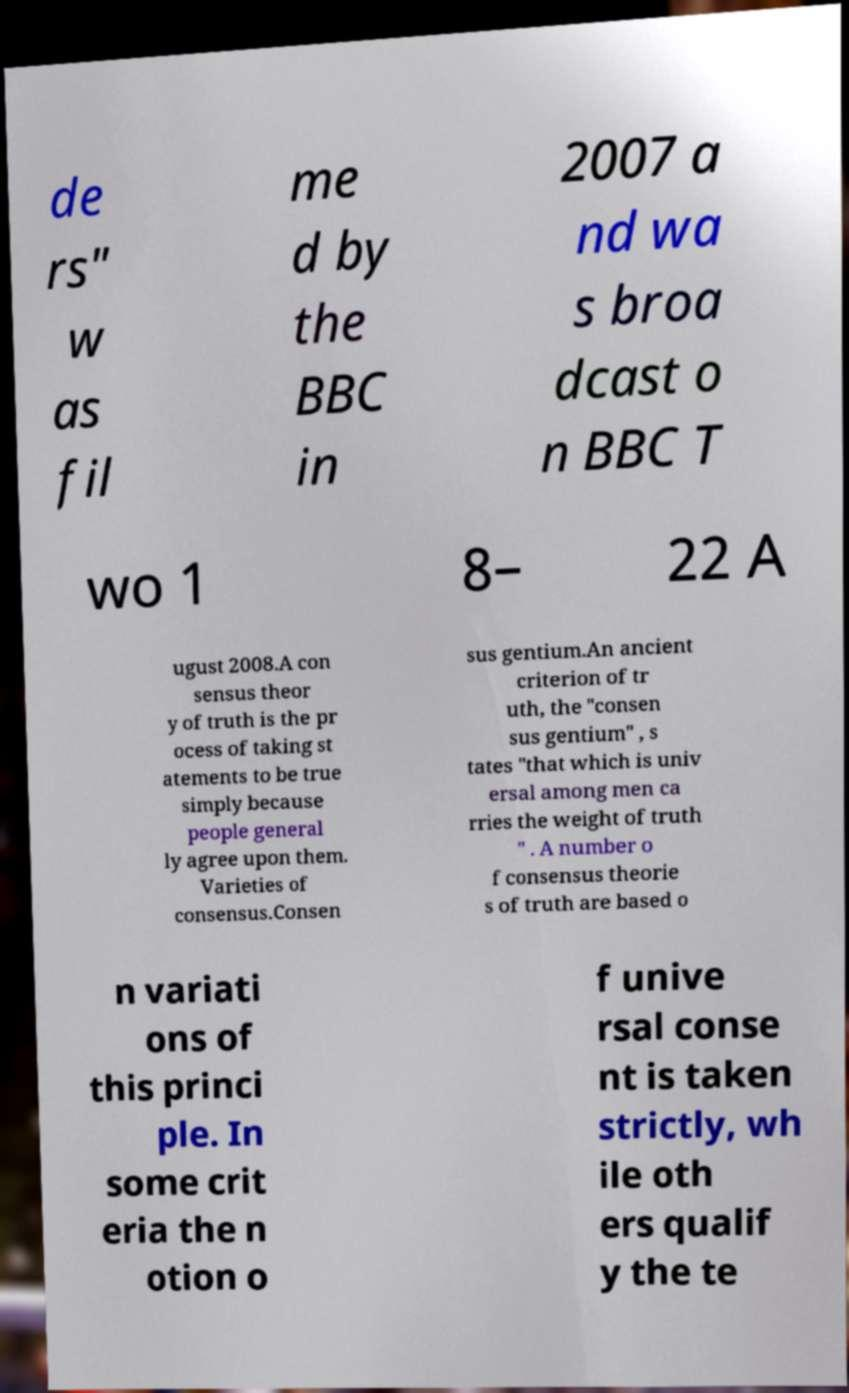Could you extract and type out the text from this image? de rs" w as fil me d by the BBC in 2007 a nd wa s broa dcast o n BBC T wo 1 8– 22 A ugust 2008.A con sensus theor y of truth is the pr ocess of taking st atements to be true simply because people general ly agree upon them. Varieties of consensus.Consen sus gentium.An ancient criterion of tr uth, the "consen sus gentium" , s tates "that which is univ ersal among men ca rries the weight of truth " . A number o f consensus theorie s of truth are based o n variati ons of this princi ple. In some crit eria the n otion o f unive rsal conse nt is taken strictly, wh ile oth ers qualif y the te 